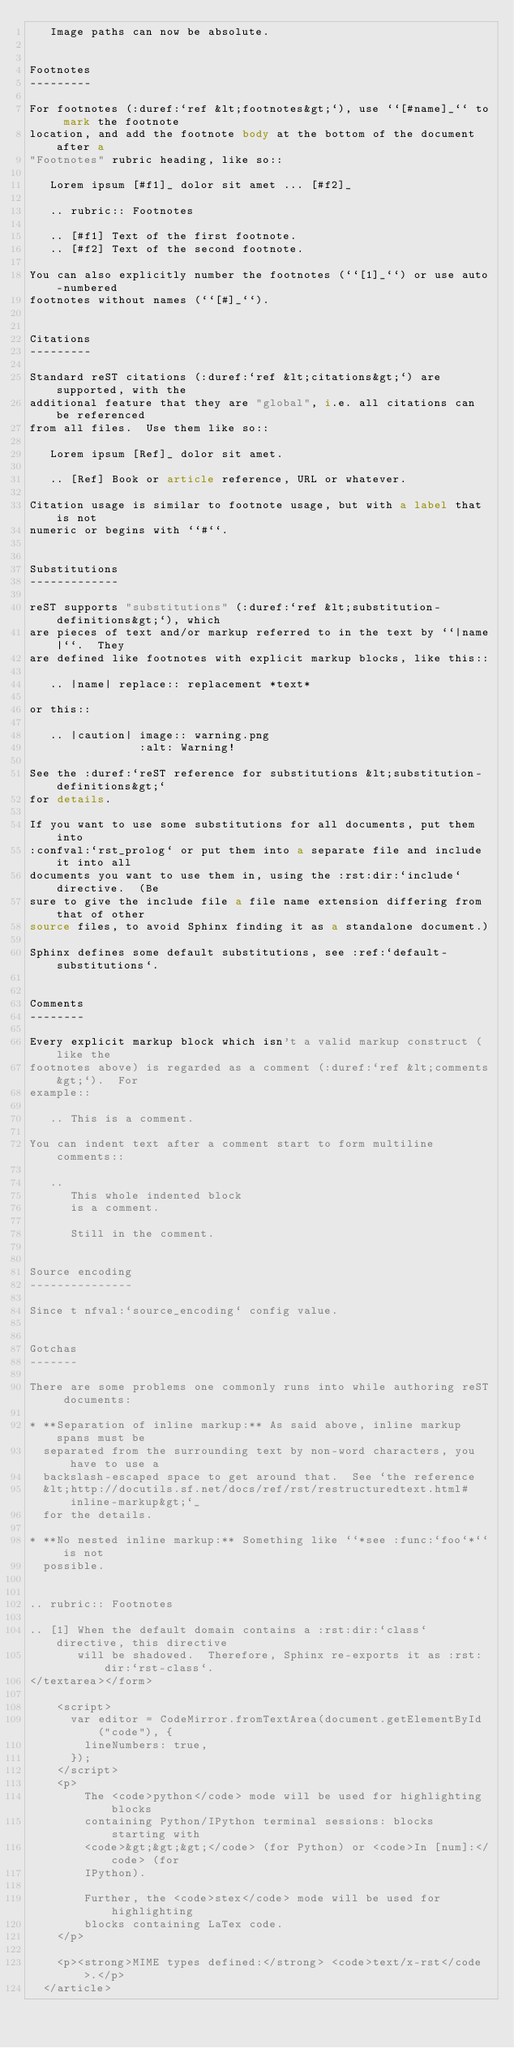<code> <loc_0><loc_0><loc_500><loc_500><_HTML_>   Image paths can now be absolute.


Footnotes
---------

For footnotes (:duref:`ref &lt;footnotes&gt;`), use ``[#name]_`` to mark the footnote
location, and add the footnote body at the bottom of the document after a
"Footnotes" rubric heading, like so::

   Lorem ipsum [#f1]_ dolor sit amet ... [#f2]_

   .. rubric:: Footnotes

   .. [#f1] Text of the first footnote.
   .. [#f2] Text of the second footnote.

You can also explicitly number the footnotes (``[1]_``) or use auto-numbered
footnotes without names (``[#]_``).


Citations
---------

Standard reST citations (:duref:`ref &lt;citations&gt;`) are supported, with the
additional feature that they are "global", i.e. all citations can be referenced
from all files.  Use them like so::

   Lorem ipsum [Ref]_ dolor sit amet.

   .. [Ref] Book or article reference, URL or whatever.

Citation usage is similar to footnote usage, but with a label that is not
numeric or begins with ``#``.


Substitutions
-------------

reST supports "substitutions" (:duref:`ref &lt;substitution-definitions&gt;`), which
are pieces of text and/or markup referred to in the text by ``|name|``.  They
are defined like footnotes with explicit markup blocks, like this::

   .. |name| replace:: replacement *text*

or this::

   .. |caution| image:: warning.png
                :alt: Warning!

See the :duref:`reST reference for substitutions &lt;substitution-definitions&gt;`
for details.

If you want to use some substitutions for all documents, put them into
:confval:`rst_prolog` or put them into a separate file and include it into all
documents you want to use them in, using the :rst:dir:`include` directive.  (Be
sure to give the include file a file name extension differing from that of other
source files, to avoid Sphinx finding it as a standalone document.)

Sphinx defines some default substitutions, see :ref:`default-substitutions`.


Comments
--------

Every explicit markup block which isn't a valid markup construct (like the
footnotes above) is regarded as a comment (:duref:`ref &lt;comments&gt;`).  For
example::

   .. This is a comment.

You can indent text after a comment start to form multiline comments::

   ..
      This whole indented block
      is a comment.

      Still in the comment.


Source encoding
---------------

Since t nfval:`source_encoding` config value.


Gotchas
-------

There are some problems one commonly runs into while authoring reST documents:

* **Separation of inline markup:** As said above, inline markup spans must be
  separated from the surrounding text by non-word characters, you have to use a
  backslash-escaped space to get around that.  See `the reference
  &lt;http://docutils.sf.net/docs/ref/rst/restructuredtext.html#inline-markup&gt;`_
  for the details.

* **No nested inline markup:** Something like ``*see :func:`foo`*`` is not
  possible.


.. rubric:: Footnotes

.. [1] When the default domain contains a :rst:dir:`class` directive, this directive
       will be shadowed.  Therefore, Sphinx re-exports it as :rst:dir:`rst-class`.
</textarea></form>

    <script>
      var editor = CodeMirror.fromTextArea(document.getElementById("code"), {
        lineNumbers: true,
      });
    </script>
    <p>
        The <code>python</code> mode will be used for highlighting blocks
        containing Python/IPython terminal sessions: blocks starting with
        <code>&gt;&gt;&gt;</code> (for Python) or <code>In [num]:</code> (for
        IPython).

        Further, the <code>stex</code> mode will be used for highlighting
        blocks containing LaTex code.
    </p>

    <p><strong>MIME types defined:</strong> <code>text/x-rst</code>.</p>
  </article>
</code> 